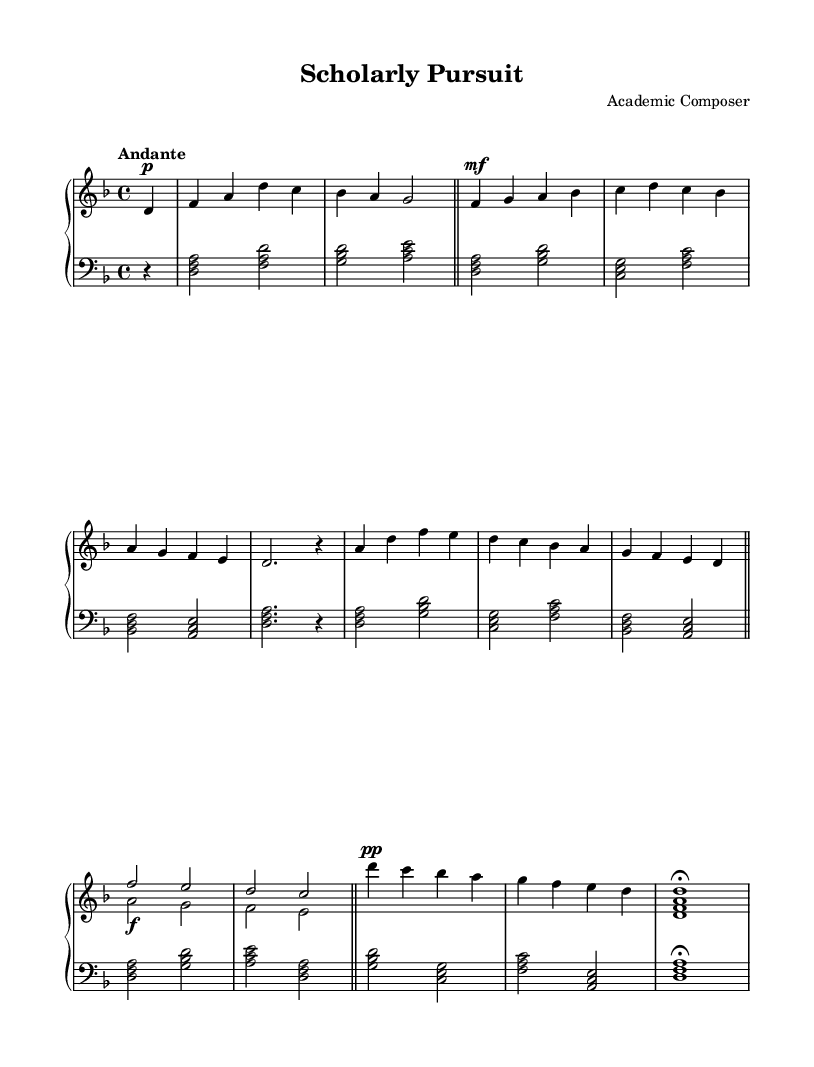What is the key signature of this music? The key signature is indicated by the number of sharps or flats at the beginning of the staff. In this case, the signature shows one flat, which corresponds to D minor.
Answer: D minor What is the time signature of this piece? The time signature is found at the beginning of the staff, indicating the division of beats per measure. Here, the time signature is 4/4, meaning there are four beats in each measure.
Answer: 4/4 What is the tempo marking for this piece? The tempo marking is indicated at the beginning of the score. It specifies the speed at which the piece should be played. In this score, the tempo is marked as "Andante," which suggests a moderately slow pace.
Answer: Andante How many themes are present in the composition? By analyzing the structure of the piece, we can identify distinct sections that qualify as themes. Here, two themes (Theme A and Theme B) are explicitly mentioned, indicating there are two main themes.
Answer: Two What dynamic marking is indicated at the start of Theme A? The dynamic marking appears before the musical notation of Theme A, specifying how loudly or softly the music should be played. In this section, the marking is “mf,” indicating that it should be played moderately loud.
Answer: mf What is the longest note value in the coda of this piece? To find the longest note value in the coda, we look at the final section's notes. The last note in the coda is a whole note, which is indicated by the absence of a stem and the length of the note itself.
Answer: Whole note 